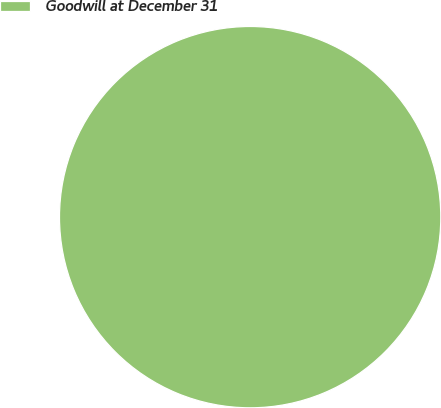Convert chart to OTSL. <chart><loc_0><loc_0><loc_500><loc_500><pie_chart><fcel>Goodwill at December 31<nl><fcel>100.0%<nl></chart> 